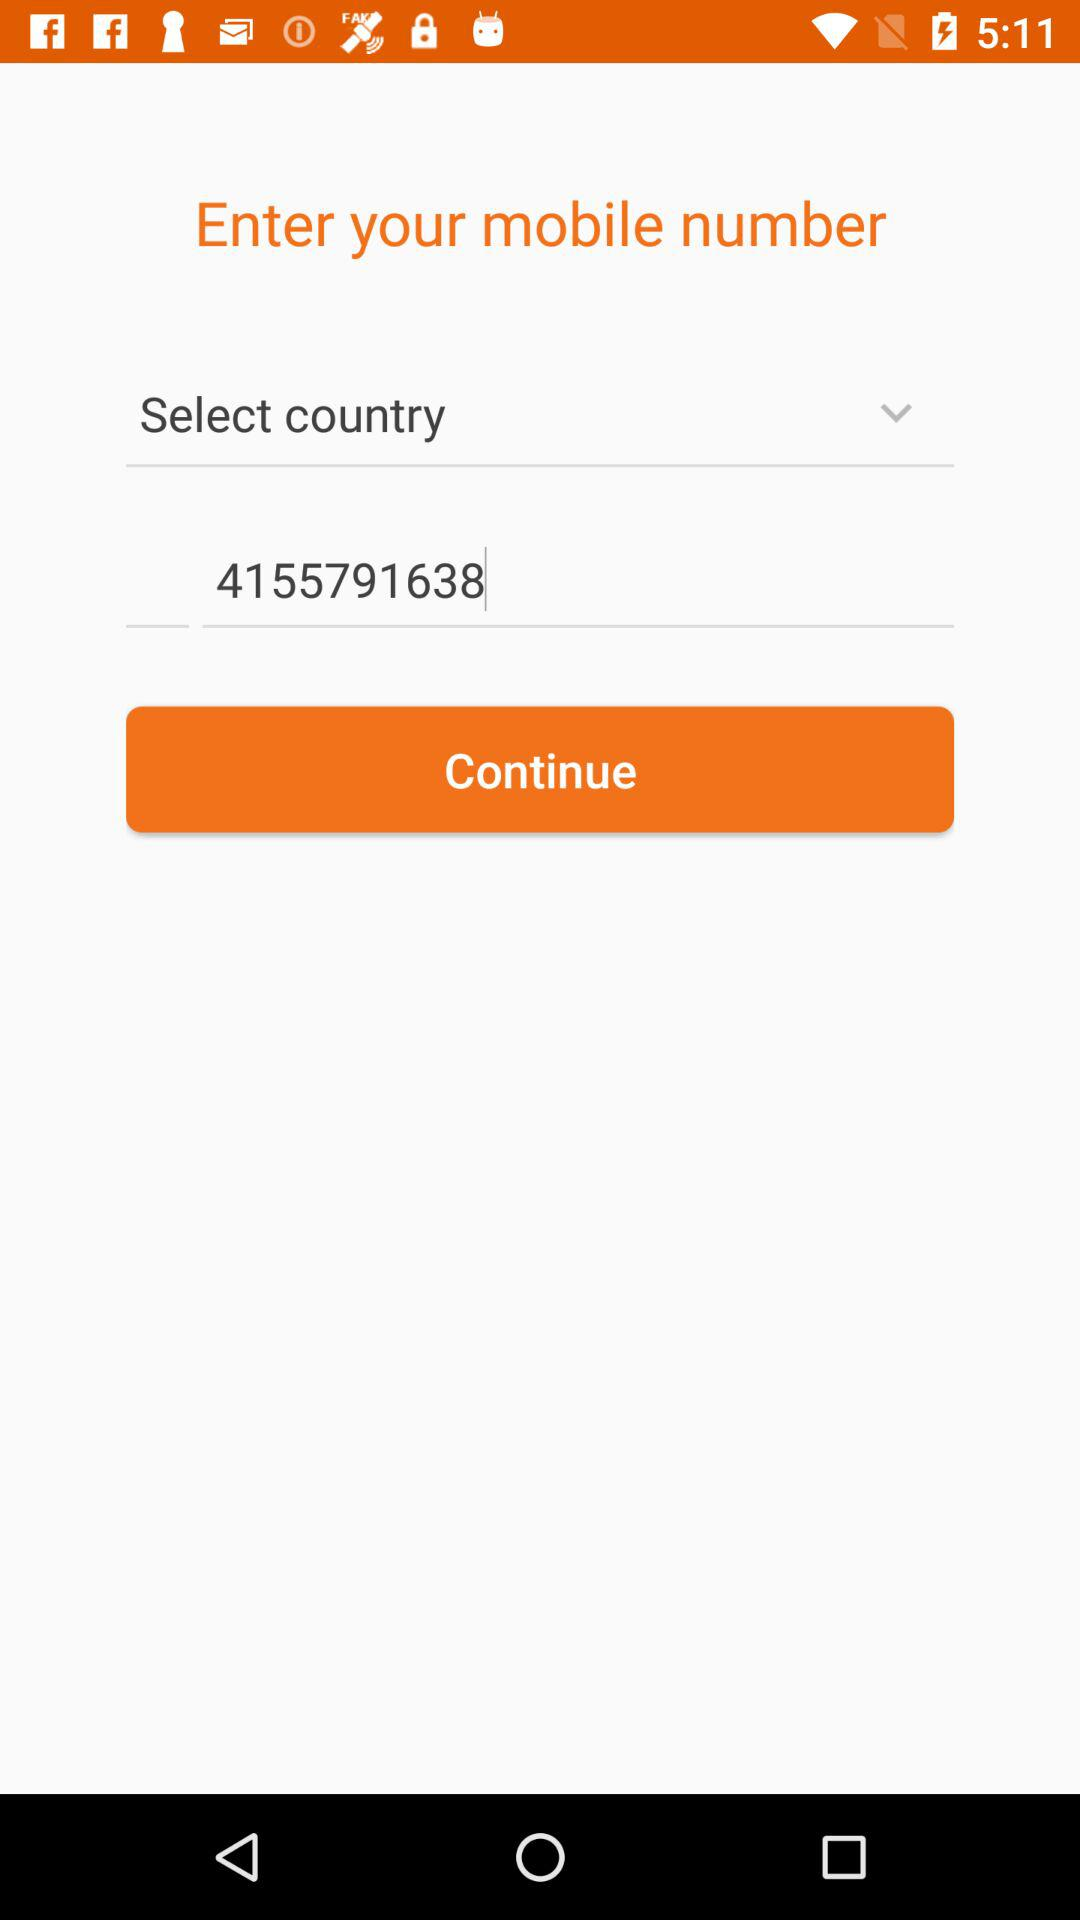How many digits are shown in the mobile number input?
Answer the question using a single word or phrase. 10 